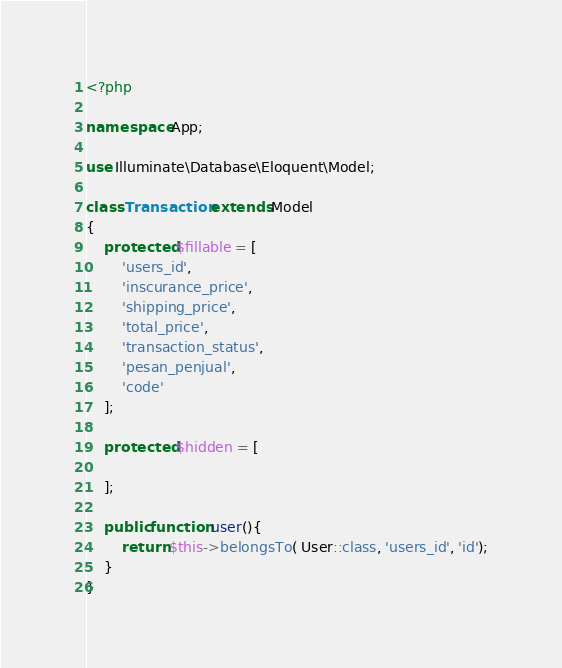<code> <loc_0><loc_0><loc_500><loc_500><_PHP_><?php

namespace App;

use Illuminate\Database\Eloquent\Model;

class Transaction extends Model
{
    protected $fillable = [
        'users_id', 
        'inscurance_price',
        'shipping_price',
        'total_price',
        'transaction_status',
        'pesan_penjual',
        'code'
    ];

    protected $hidden = [

    ];

    public function user(){
        return $this->belongsTo( User::class, 'users_id', 'id');
    }
}
</code> 